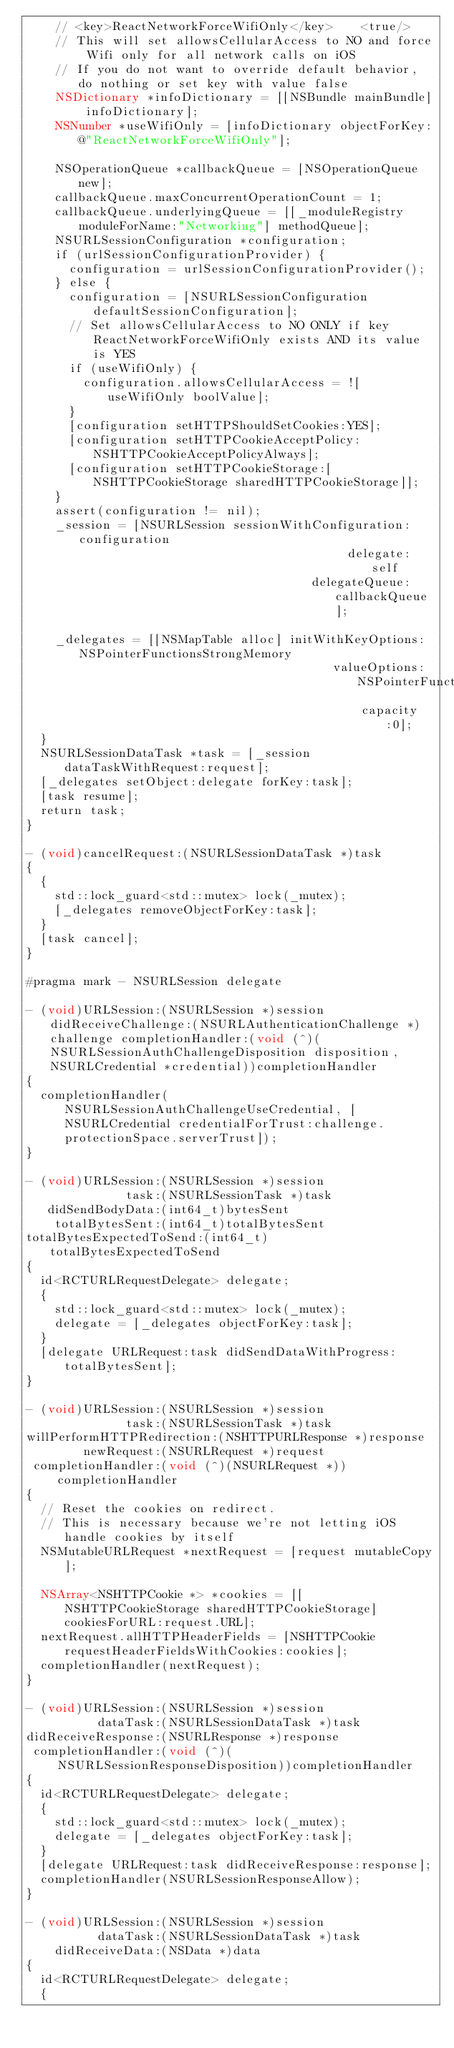<code> <loc_0><loc_0><loc_500><loc_500><_ObjectiveC_>    // <key>ReactNetworkForceWifiOnly</key>    <true/>
    // This will set allowsCellularAccess to NO and force Wifi only for all network calls on iOS
    // If you do not want to override default behavior, do nothing or set key with value false
    NSDictionary *infoDictionary = [[NSBundle mainBundle] infoDictionary];
    NSNumber *useWifiOnly = [infoDictionary objectForKey:@"ReactNetworkForceWifiOnly"];

    NSOperationQueue *callbackQueue = [NSOperationQueue new];
    callbackQueue.maxConcurrentOperationCount = 1;
    callbackQueue.underlyingQueue = [[_moduleRegistry moduleForName:"Networking"] methodQueue];
    NSURLSessionConfiguration *configuration;
    if (urlSessionConfigurationProvider) {
      configuration = urlSessionConfigurationProvider();
    } else {
      configuration = [NSURLSessionConfiguration defaultSessionConfiguration];
      // Set allowsCellularAccess to NO ONLY if key ReactNetworkForceWifiOnly exists AND its value is YES
      if (useWifiOnly) {
        configuration.allowsCellularAccess = ![useWifiOnly boolValue];
      }
      [configuration setHTTPShouldSetCookies:YES];
      [configuration setHTTPCookieAcceptPolicy:NSHTTPCookieAcceptPolicyAlways];
      [configuration setHTTPCookieStorage:[NSHTTPCookieStorage sharedHTTPCookieStorage]];
    }
    assert(configuration != nil);
    _session = [NSURLSession sessionWithConfiguration:configuration
                                             delegate:self
                                        delegateQueue:callbackQueue];

    _delegates = [[NSMapTable alloc] initWithKeyOptions:NSPointerFunctionsStrongMemory
                                           valueOptions:NSPointerFunctionsStrongMemory
                                               capacity:0];
  }
  NSURLSessionDataTask *task = [_session dataTaskWithRequest:request];
  [_delegates setObject:delegate forKey:task];
  [task resume];
  return task;
}

- (void)cancelRequest:(NSURLSessionDataTask *)task
{
  {
    std::lock_guard<std::mutex> lock(_mutex);
    [_delegates removeObjectForKey:task];
  }
  [task cancel];
}

#pragma mark - NSURLSession delegate

- (void)URLSession:(NSURLSession *)session didReceiveChallenge:(NSURLAuthenticationChallenge *)challenge completionHandler:(void (^)(NSURLSessionAuthChallengeDisposition disposition, NSURLCredential *credential))completionHandler
{
  completionHandler(NSURLSessionAuthChallengeUseCredential, [NSURLCredential credentialForTrust:challenge.protectionSpace.serverTrust]);
}

- (void)URLSession:(NSURLSession *)session
              task:(NSURLSessionTask *)task
   didSendBodyData:(int64_t)bytesSent
    totalBytesSent:(int64_t)totalBytesSent
totalBytesExpectedToSend:(int64_t)totalBytesExpectedToSend
{
  id<RCTURLRequestDelegate> delegate;
  {
    std::lock_guard<std::mutex> lock(_mutex);
    delegate = [_delegates objectForKey:task];
  }
  [delegate URLRequest:task didSendDataWithProgress:totalBytesSent];
}

- (void)URLSession:(NSURLSession *)session
              task:(NSURLSessionTask *)task
willPerformHTTPRedirection:(NSHTTPURLResponse *)response
        newRequest:(NSURLRequest *)request
 completionHandler:(void (^)(NSURLRequest *))completionHandler
{
  // Reset the cookies on redirect.
  // This is necessary because we're not letting iOS handle cookies by itself
  NSMutableURLRequest *nextRequest = [request mutableCopy];

  NSArray<NSHTTPCookie *> *cookies = [[NSHTTPCookieStorage sharedHTTPCookieStorage] cookiesForURL:request.URL];
  nextRequest.allHTTPHeaderFields = [NSHTTPCookie requestHeaderFieldsWithCookies:cookies];
  completionHandler(nextRequest);
}

- (void)URLSession:(NSURLSession *)session
          dataTask:(NSURLSessionDataTask *)task
didReceiveResponse:(NSURLResponse *)response
 completionHandler:(void (^)(NSURLSessionResponseDisposition))completionHandler
{
  id<RCTURLRequestDelegate> delegate;
  {
    std::lock_guard<std::mutex> lock(_mutex);
    delegate = [_delegates objectForKey:task];
  }
  [delegate URLRequest:task didReceiveResponse:response];
  completionHandler(NSURLSessionResponseAllow);
}

- (void)URLSession:(NSURLSession *)session
          dataTask:(NSURLSessionDataTask *)task
    didReceiveData:(NSData *)data
{
  id<RCTURLRequestDelegate> delegate;
  {</code> 